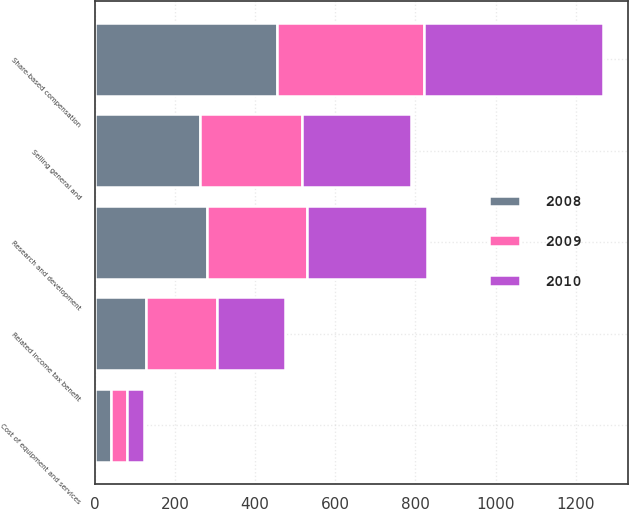Convert chart to OTSL. <chart><loc_0><loc_0><loc_500><loc_500><stacked_bar_chart><ecel><fcel>Cost of equipment and services<fcel>Research and development<fcel>Selling general and<fcel>Share-based compensation<fcel>Related income tax benefit<nl><fcel>2010<fcel>42<fcel>300<fcel>273<fcel>445<fcel>170<nl><fcel>2008<fcel>41<fcel>280<fcel>263<fcel>455<fcel>129<nl><fcel>2009<fcel>39<fcel>250<fcel>254<fcel>367<fcel>176<nl></chart> 